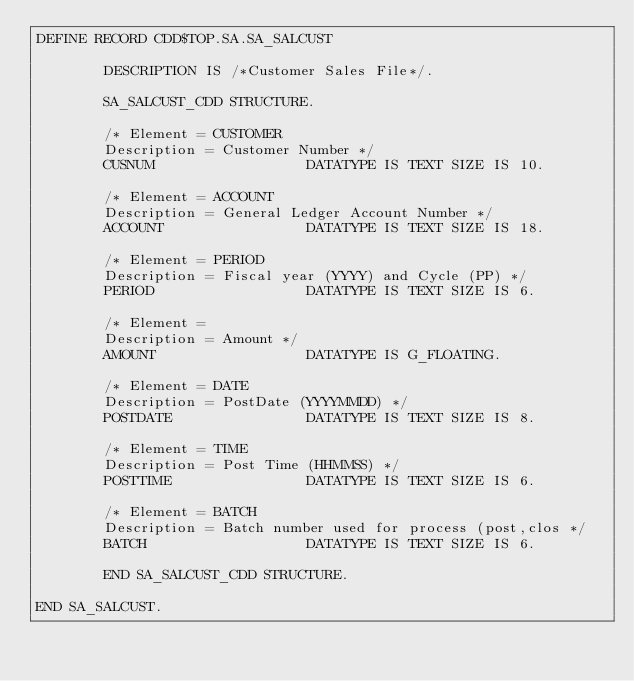<code> <loc_0><loc_0><loc_500><loc_500><_SQL_>DEFINE RECORD CDD$TOP.SA.SA_SALCUST

        DESCRIPTION IS /*Customer Sales File*/.

        SA_SALCUST_CDD STRUCTURE.

        /* Element = CUSTOMER
        Description = Customer Number */
        CUSNUM                  DATATYPE IS TEXT SIZE IS 10.

        /* Element = ACCOUNT
        Description = General Ledger Account Number */
        ACCOUNT                 DATATYPE IS TEXT SIZE IS 18.

        /* Element = PERIOD
        Description = Fiscal year (YYYY) and Cycle (PP) */
        PERIOD                  DATATYPE IS TEXT SIZE IS 6.

        /* Element =
        Description = Amount */
        AMOUNT                  DATATYPE IS G_FLOATING.

        /* Element = DATE
        Description = PostDate (YYYYMMDD) */
        POSTDATE                DATATYPE IS TEXT SIZE IS 8.

        /* Element = TIME
        Description = Post Time (HHMMSS) */
        POSTTIME                DATATYPE IS TEXT SIZE IS 6.

        /* Element = BATCH
        Description = Batch number used for process (post,clos */
        BATCH                   DATATYPE IS TEXT SIZE IS 6.

        END SA_SALCUST_CDD STRUCTURE.

END SA_SALCUST.
</code> 